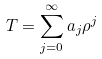<formula> <loc_0><loc_0><loc_500><loc_500>T = \sum _ { j = 0 } ^ { \infty } a _ { j } \rho ^ { j }</formula> 